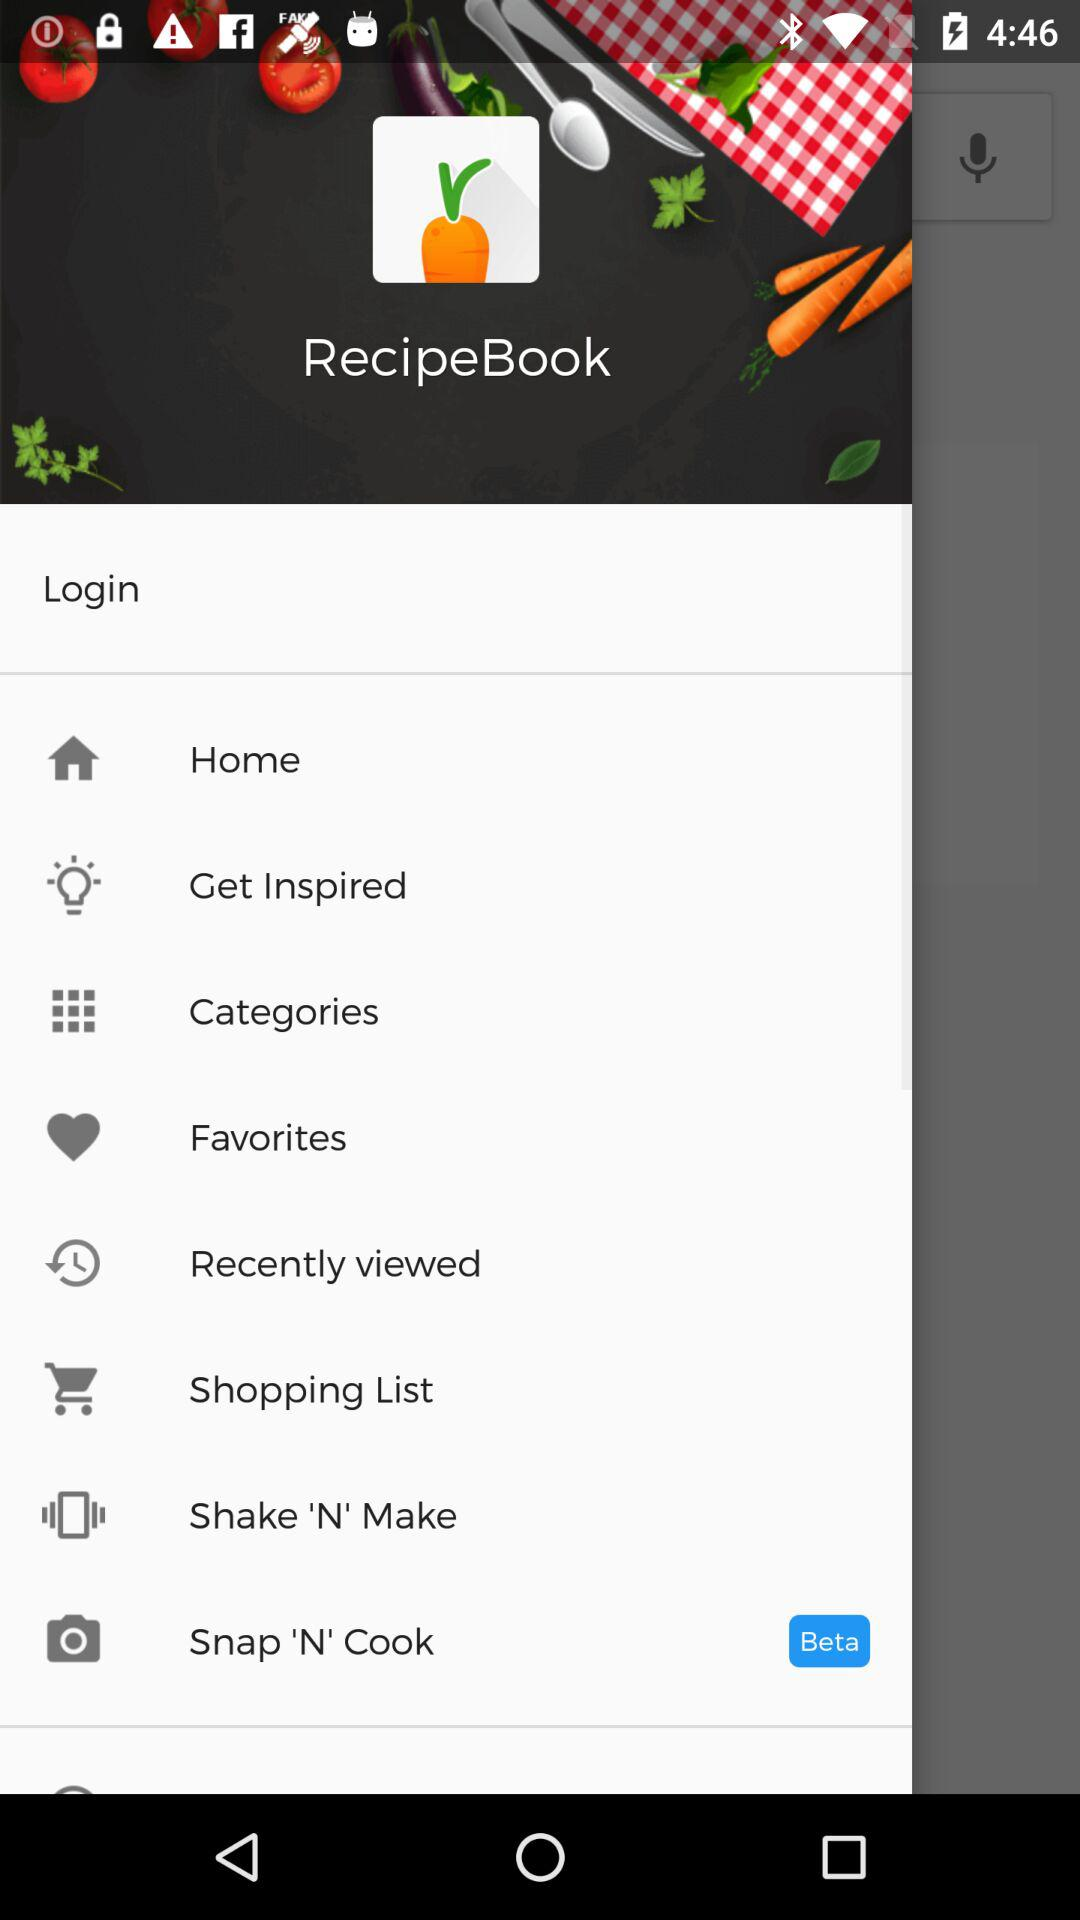What is the name of the application? The name of the application is "RecipeBook". 